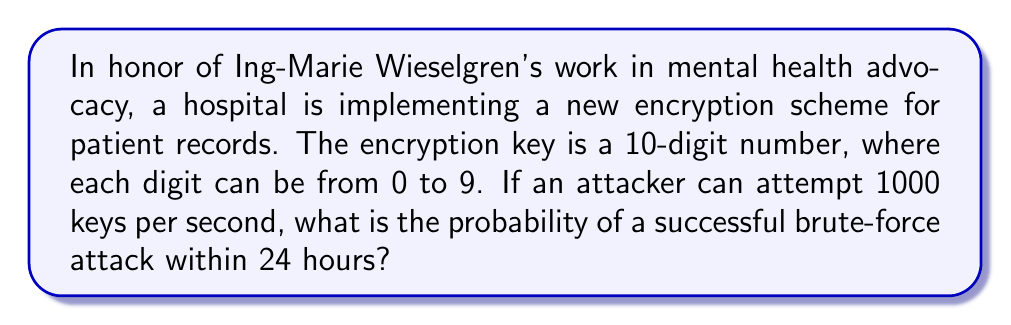Can you answer this question? Let's approach this step-by-step:

1) First, we need to calculate the total number of possible keys:
   $$ \text{Total keys} = 10^{10} $$
   This is because there are 10 choices (0-9) for each of the 10 digits.

2) Next, we calculate how many attempts the attacker can make in 24 hours:
   $$ \text{Attempts in 24 hours} = 1000 \text{ attempts/second} \times 3600 \text{ seconds/hour} \times 24 \text{ hours} $$
   $$ = 86,400,000 \text{ attempts} $$

3) The probability of success is the number of attempts divided by the total number of possible keys:
   $$ P(\text{success}) = \frac{\text{Number of attempts}}{\text{Total number of keys}} $$
   $$ = \frac{86,400,000}{10^{10}} = \frac{86,400,000}{10,000,000,000} = 0.00864 $$

4) We can express this as a percentage:
   $$ 0.00864 \times 100\% = 0.864\% $$

Therefore, the probability of a successful brute-force attack within 24 hours is approximately 0.864%.
Answer: $0.864\%$ 